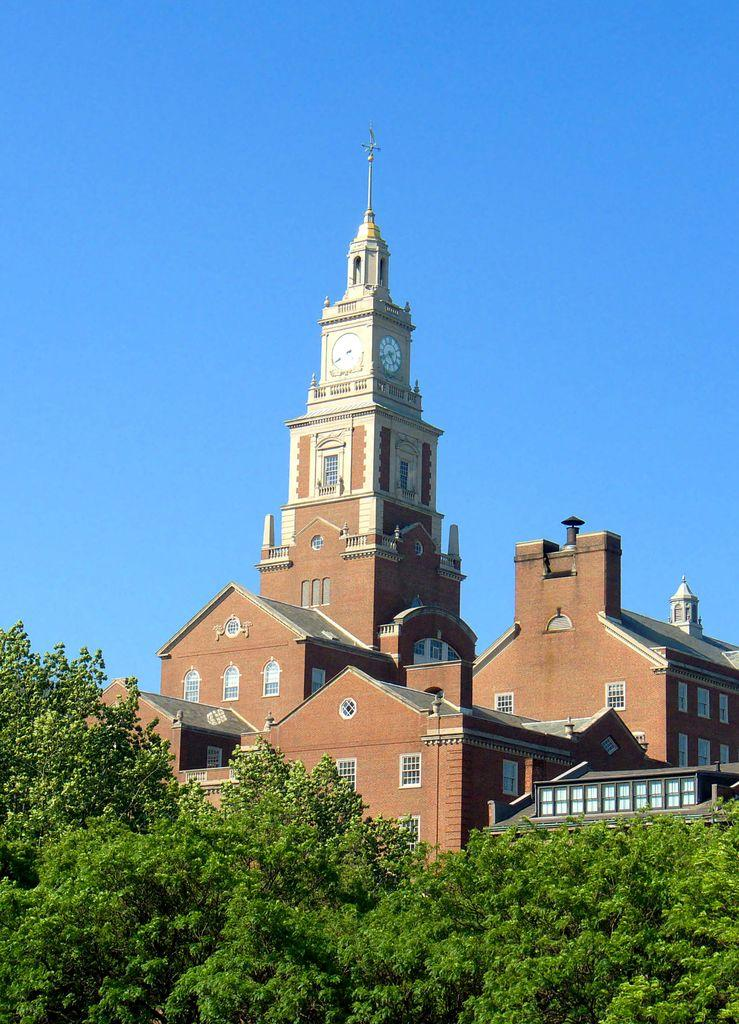What is the main subject in the center of the image? There is a building in the center of the image. What type of vegetation can be seen at the bottom of the image? Trees are visible at the bottom of the image. What part of the natural environment is visible in the background of the image? The sky is visible in the background of the image. What type of plastic material can be seen expanding in the image? There is no plastic material visible in the image, nor is there any indication of expansion. 